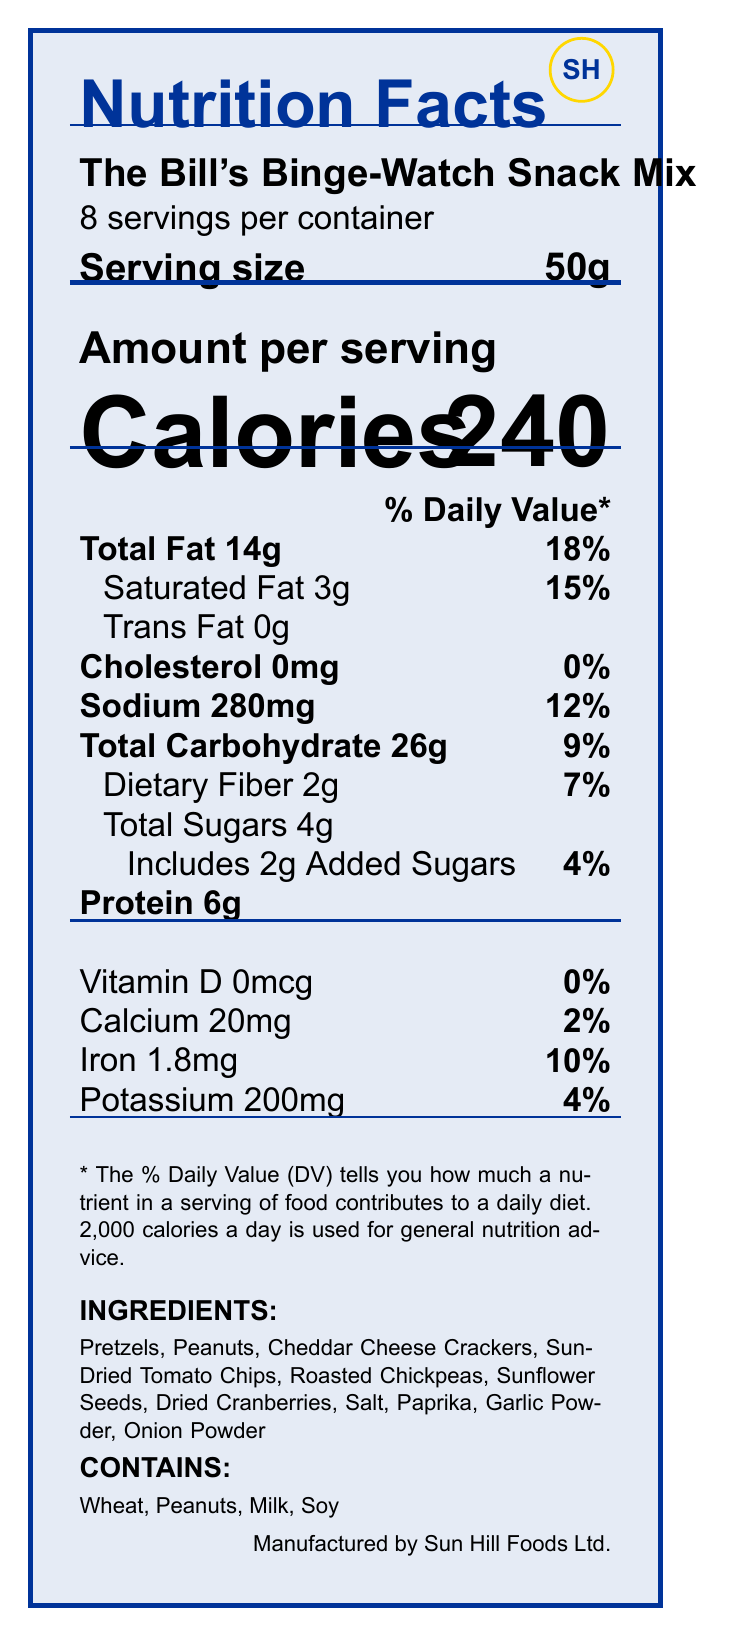what is the serving size? The serving size is specified as 50g in the document.
Answer: 50g how many servings are in one container? The document states that there are 8 servings per container.
Answer: 8 how many calories are in one serving? The document lists that each serving has 240 calories.
Answer: 240 what percentage of daily value is total fat per serving? The total fat per serving has a daily value percentage of 18%, as shown in the document.
Answer: 18% how much sodium is in one serving? The sodium content per serving is listed as 280mg.
Answer: 280mg which ingredient gives the pretzel its unique design? Thematic elements specify that the pretzel shape is inspired by the Sun Hill Police Badge.
Answer: Sun Hill Police Badge how much saturated fat is in a serving? The document states that one serving contains 3g of saturated fat.
Answer: 3g what is the percentage of daily value for iron? A. 4% B. 7% C. 10% D. 15% The daily value percentage for iron per serving is 10%, as indicated in the document.
Answer: C. 10% what allergen is NOT found in this snack mix? A. Peanuts B. Wheat C. Milk D. Eggs The allergen information lists wheat, peanuts, milk, and soy, but not eggs.
Answer: D. Eggs how much protein is in one serving? The document states that one serving contains 6g of protein.
Answer: 6g does this snack mix include any added sugars? The document indicates that there are 2g of added sugars in each serving.
Answer: Yes describe one thematic element incorporated into the snack mix The document mentions that the Cheddar cheese cracker design resembles Sergeant's Stripes.
Answer: Sergeant's Stripes what company manufactures this snack mix? The document indicates that Sun Hill Foods Ltd. is the manufacturer.
Answer: Sun Hill Foods Ltd. how should the snack mix be stored? The storage instructions specify keeping the mix in a cool, dry place and resealing the package to maintain freshness.
Answer: In a cool, dry place. Reseal package after opening to maintain freshness. what does the fun fact say about the snack mix? The fun fact describes the inspiration behind the snack mix and its flavors.
Answer: This snack mix is inspired by the diverse characters of 'The Bill', combining savory and tangy flavors to keep you energized through marathon viewing sessions. which ingredient is NOT listed in the ingredients? A. Dried Cranberries B. Cashews C. Sunflower Seeds D. Paprika Cashews are not listed; the ingredients include pretzels, peanuts, cheddar cheese crackers, sun-dried tomato chips, roasted chickpeas, sunflower seeds, dried cranberries, salt, paprika, garlic powder, and onion powder.
Answer: B. Cashews is the document visually appealing with colors and shapes related to 'The Bill'? The document uses colors like sunhillblue and policebadge that relate to 'The Bill', as well as shapes and designs themed around the show.
Answer: Yes summarize the thematic elements of 'The Bill's Binge-Watch Snack Mix' The thematic elements are creatively tied to 'The Bill', including specific designs for shapes and colors.
Answer: The thematic elements include shapes and colors inspired by 'The Bill' such as pretzels shaped like the Sun Hill Police Badge, cheddar cheese crackers designed to resemble Sergeant's Stripes, and the packaging color called Metropolitan Police Blue. name one flavoring ingredient used in the snack mix (e.g., spice or seasoning) The document lists paprika as one of the ingredients used for flavoring.
Answer: Paprika how much calcium is in one serving? The document indicates that each serving contains 20mg of calcium.
Answer: 20mg what is the total weight of the snack mix in one container? With 8 servings of 50g each, the total weight is 8 x 50g = 400g.
Answer: 400g what percentage of daily value for potassium is in one serving? The daily value percentage for potassium per serving is 4%, as given in the document.
Answer: 4% how many total grams of sugar are in one serving? The document lists 4g of total sugars per serving.
Answer: 4g what year did 'The Bill' first air on TV? The provided document does not contain information about the first air date of 'The Bill'.
Answer: Cannot be determined 